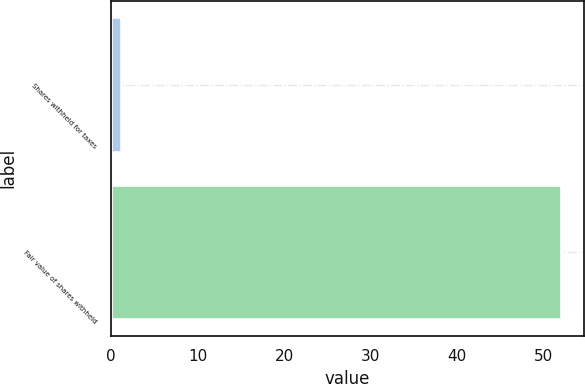Convert chart. <chart><loc_0><loc_0><loc_500><loc_500><bar_chart><fcel>Shares withheld for taxes<fcel>Fair value of shares withheld<nl><fcel>1.2<fcel>52<nl></chart> 